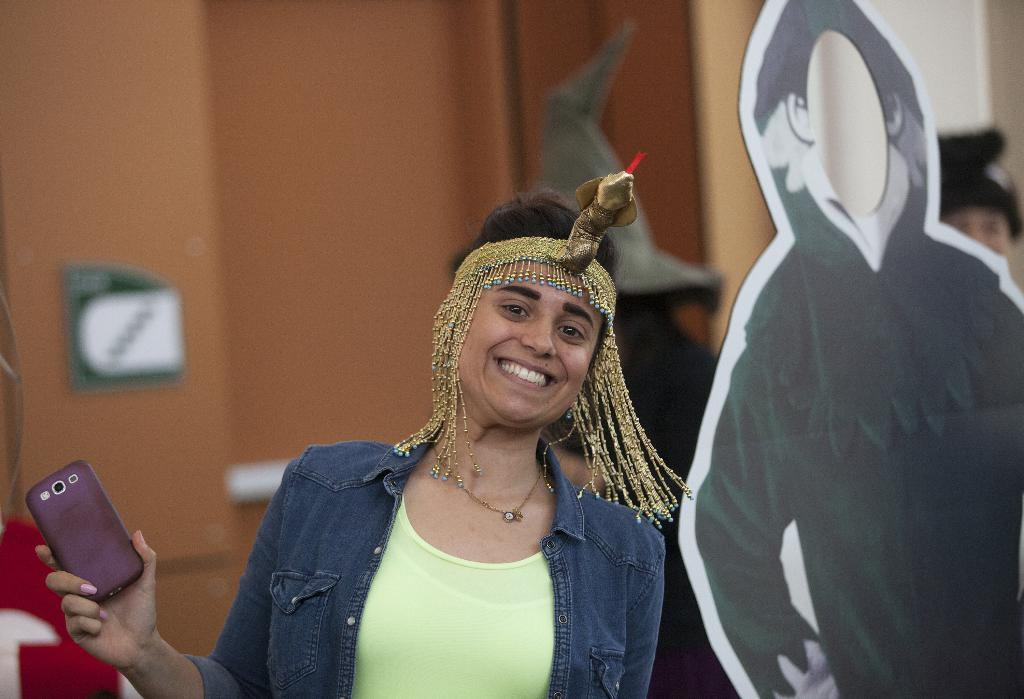Who is the main subject in the image? There is a lady in the image. What is the lady wearing on her head? The lady is wearing a headband. What object is the lady holding in her hand? The lady is holding a mobile phone. What can be seen beside the lady? There is a board beside the lady. What type of force is being applied to the board in the image? There is no indication of any force being applied to the board in the image. 